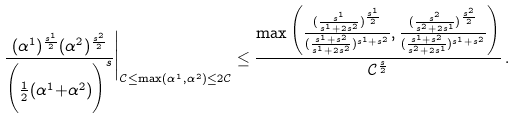<formula> <loc_0><loc_0><loc_500><loc_500>\frac { ( \alpha ^ { 1 } ) ^ { \frac { s ^ { 1 } } { 2 } } ( \alpha ^ { 2 } ) ^ { \frac { s ^ { 2 } } { 2 } } } { \Big ( \frac { 1 } { 2 } ( \alpha ^ { 1 } { + } \alpha ^ { 2 } ) \Big ) ^ { s } } \Big | _ { \mathcal { C } \leq \max ( \alpha ^ { 1 } , \alpha ^ { 2 } ) \leq 2 \mathcal { C } } \leq \frac { \max \Big ( \frac { ( \frac { s ^ { 1 } } { s ^ { 1 } + 2 s ^ { 2 } } ) ^ { \frac { s ^ { 1 } } { 2 } } } { ( \frac { s ^ { 1 } + s ^ { 2 } } { s ^ { 1 } + 2 s ^ { 2 } } ) ^ { s ^ { 1 } + s ^ { 2 } } } , \frac { ( \frac { s ^ { 2 } } { s ^ { 2 } + 2 s ^ { 1 } } ) ^ { \frac { s ^ { 2 } } { 2 } } } { ( \frac { s ^ { 1 } + s ^ { 2 } } { s ^ { 2 } + 2 s ^ { 1 } } ) ^ { s ^ { 1 } + s ^ { 2 } } } \Big ) } { \mathcal { C } ^ { \frac { s } { 2 } } } \, .</formula> 